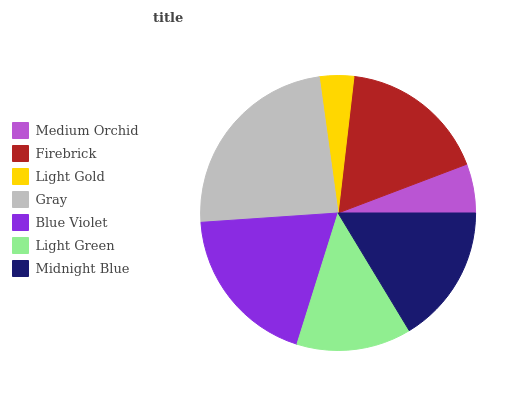Is Light Gold the minimum?
Answer yes or no. Yes. Is Gray the maximum?
Answer yes or no. Yes. Is Firebrick the minimum?
Answer yes or no. No. Is Firebrick the maximum?
Answer yes or no. No. Is Firebrick greater than Medium Orchid?
Answer yes or no. Yes. Is Medium Orchid less than Firebrick?
Answer yes or no. Yes. Is Medium Orchid greater than Firebrick?
Answer yes or no. No. Is Firebrick less than Medium Orchid?
Answer yes or no. No. Is Midnight Blue the high median?
Answer yes or no. Yes. Is Midnight Blue the low median?
Answer yes or no. Yes. Is Firebrick the high median?
Answer yes or no. No. Is Gray the low median?
Answer yes or no. No. 